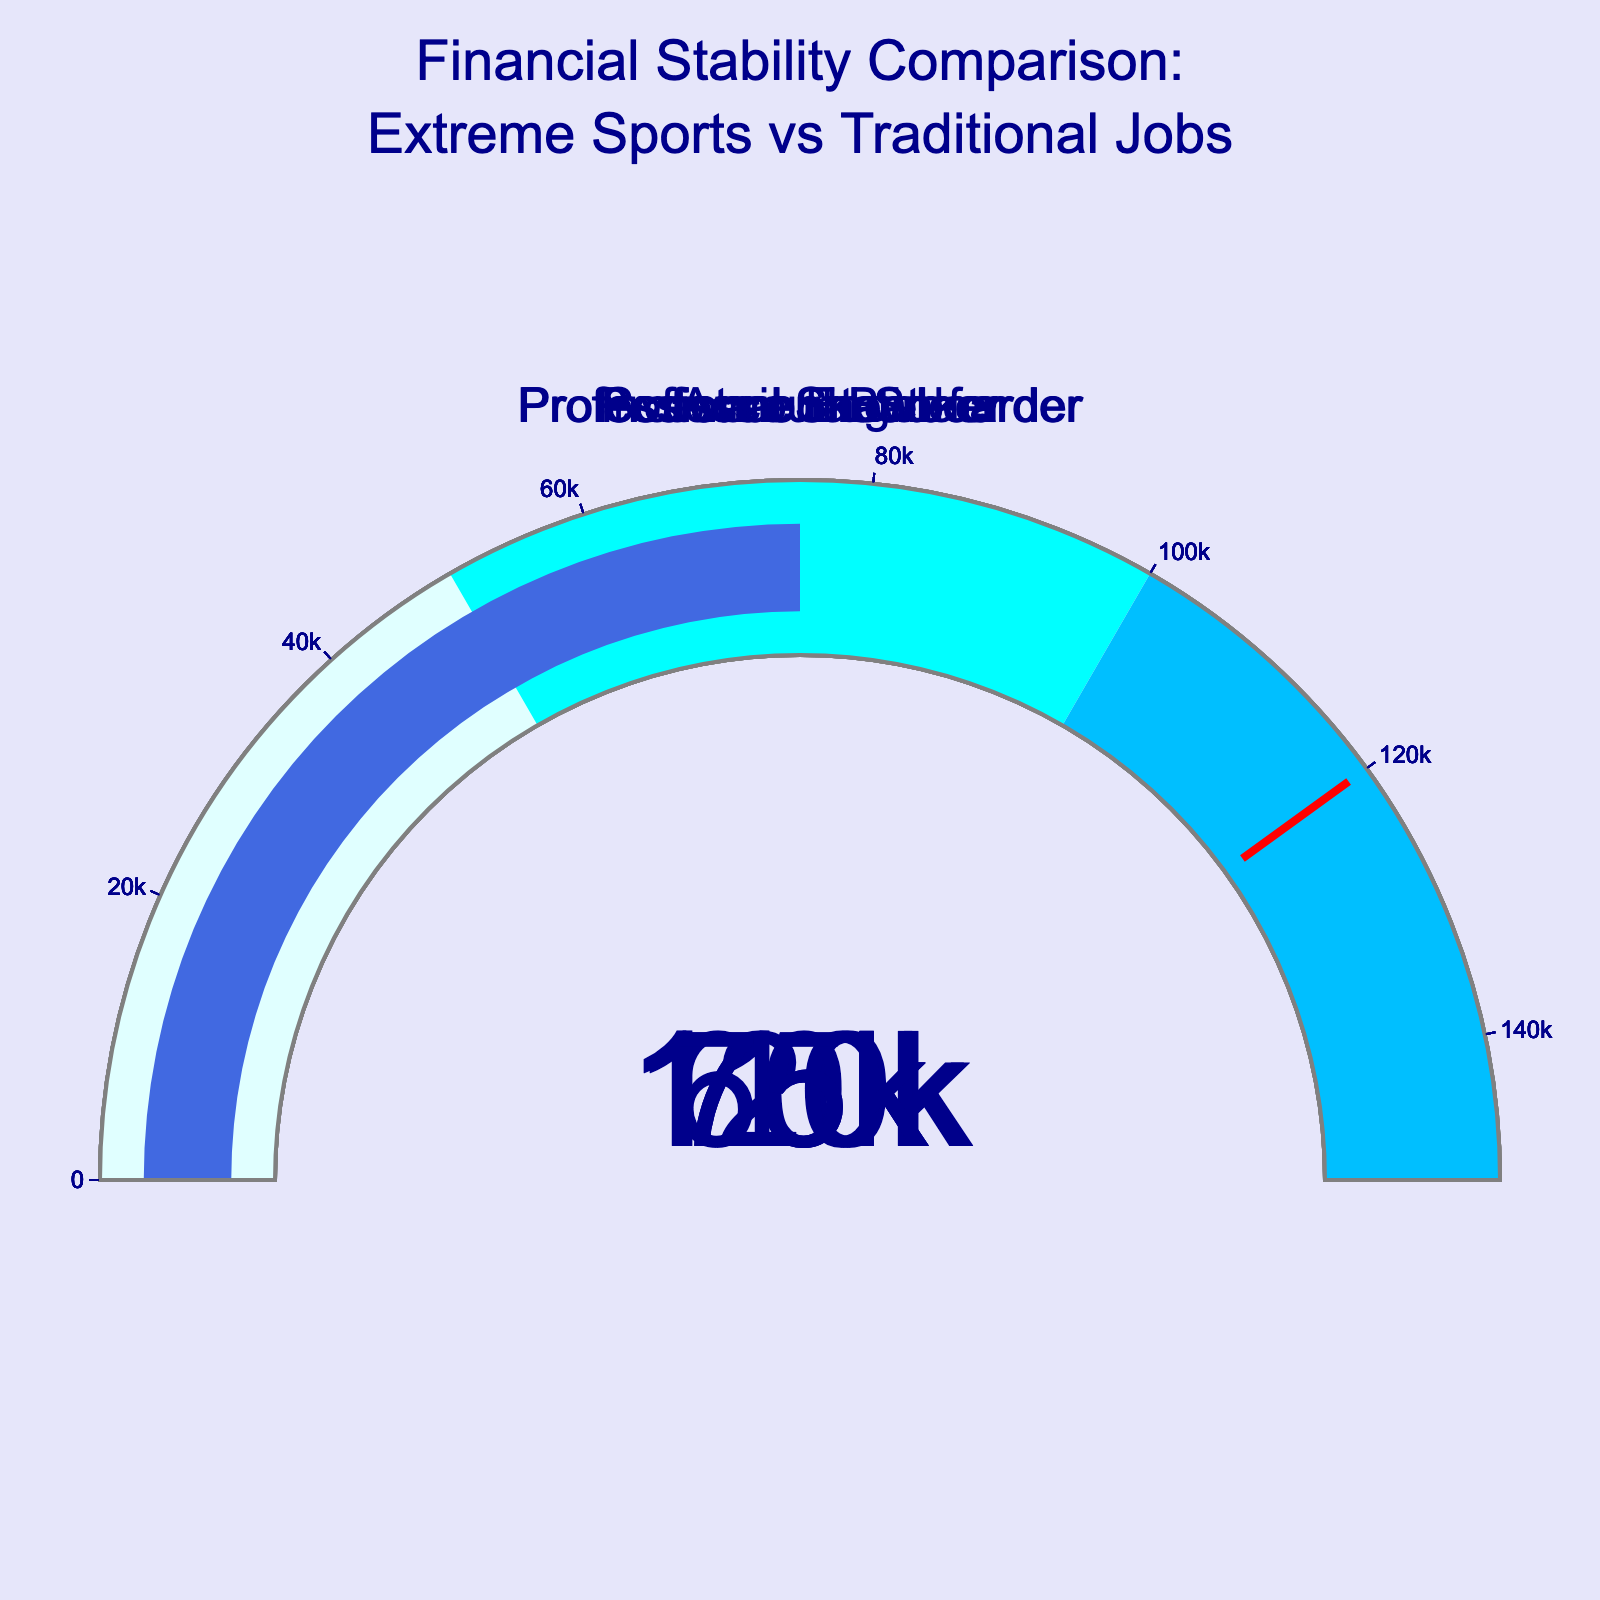Which career has the highest average annual income? The gauge chart shows the value on the gauges for different careers. The highest value is seen in the Investment Banker gauge at $120,000.
Answer: Investment Banker What is the average annual income of a Software Engineer? Refer to the Software Engineer gauge in the chart to find the displayed number. It shows $110,000.
Answer: $110,000 Compare the average annual income of a Professional Surfer to an Accountant. Which one is higher? Look at the gauges for Professional Surfer and Accountant. Professional Surfer shows $70,000 while Accountant shows $75,000. The Accountant's income is higher.
Answer: Accountant Calculate the average annual income of all extreme sports careers combined. Add the values of Professional Snowboarder ($75,000), Professional Skateboarder ($65,000), and Professional Surfer ($70,000). The total is $210,000. Divide this by the number of extreme sports careers (3) for the average: $210,000 / 3 = $70,000.
Answer: $70,000 Is there any career with an average annual income below $60,000? Check all the gauges. The lowest values are $65,000 for Professional Skateboarder and $70,000 for Professional Surfer. None of the gauges show a value below $60,000.
Answer: No By how much does the average annual income of Investment Banker exceed that of a Professional Skateboarder? Subtract the value of Professional Skateboarder ($65,000) from Investment Banker ($120,000): $120,000 - $65,000 = $55,000.
Answer: $55,000 What is the average annual income for all traditional jobs listed? Add the values for Investment Banker ($120,000), Software Engineer ($110,000), and Accountant ($75,000). The total is $305,000. Divide by the number of traditional jobs (3): $305,000 / 3 = $101,667.
Answer: $101,667 Which career’s income is exactly equal to $75,000 according to the chart? Check all the gauges and find the one displaying $75,000. Both Professional Snowboarder and Accountant show this value.
Answer: Professional Snowboarder and Accountant What’s the difference between the highest and lowest incomes among all the careers? Identify the highest income ($120,000 for Investment Banker) and the lowest income ($65,000 for Professional Skateboarder). Subtract the lowest from the highest: $120,000 - $65,000 = $55,000.
Answer: $55,000 How many careers have incomes displayed in the light cyan color range ($0-$50,000)? Refer to the gauge colors. The light cyan range covers $0-$50,000. No gauges display values within this range.
Answer: 0 